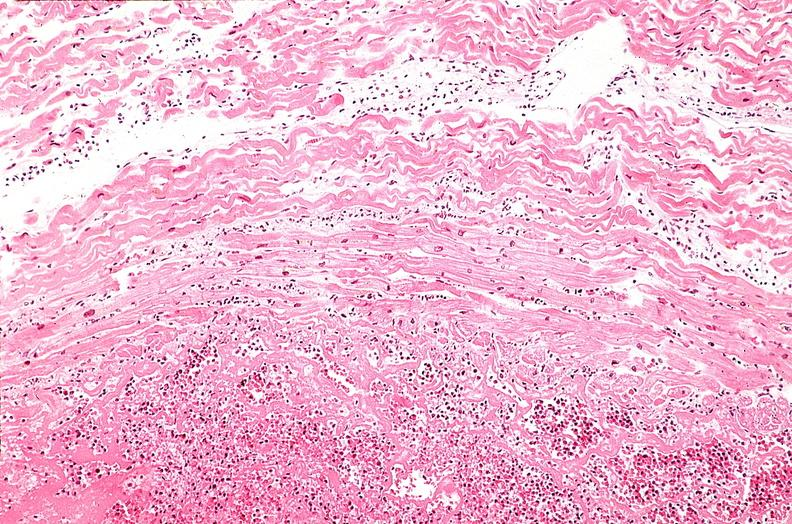does this image show heart, myocardial infarction, wavey fiber change, necrtosis, hemorrhage, and dissection?
Answer the question using a single word or phrase. Yes 